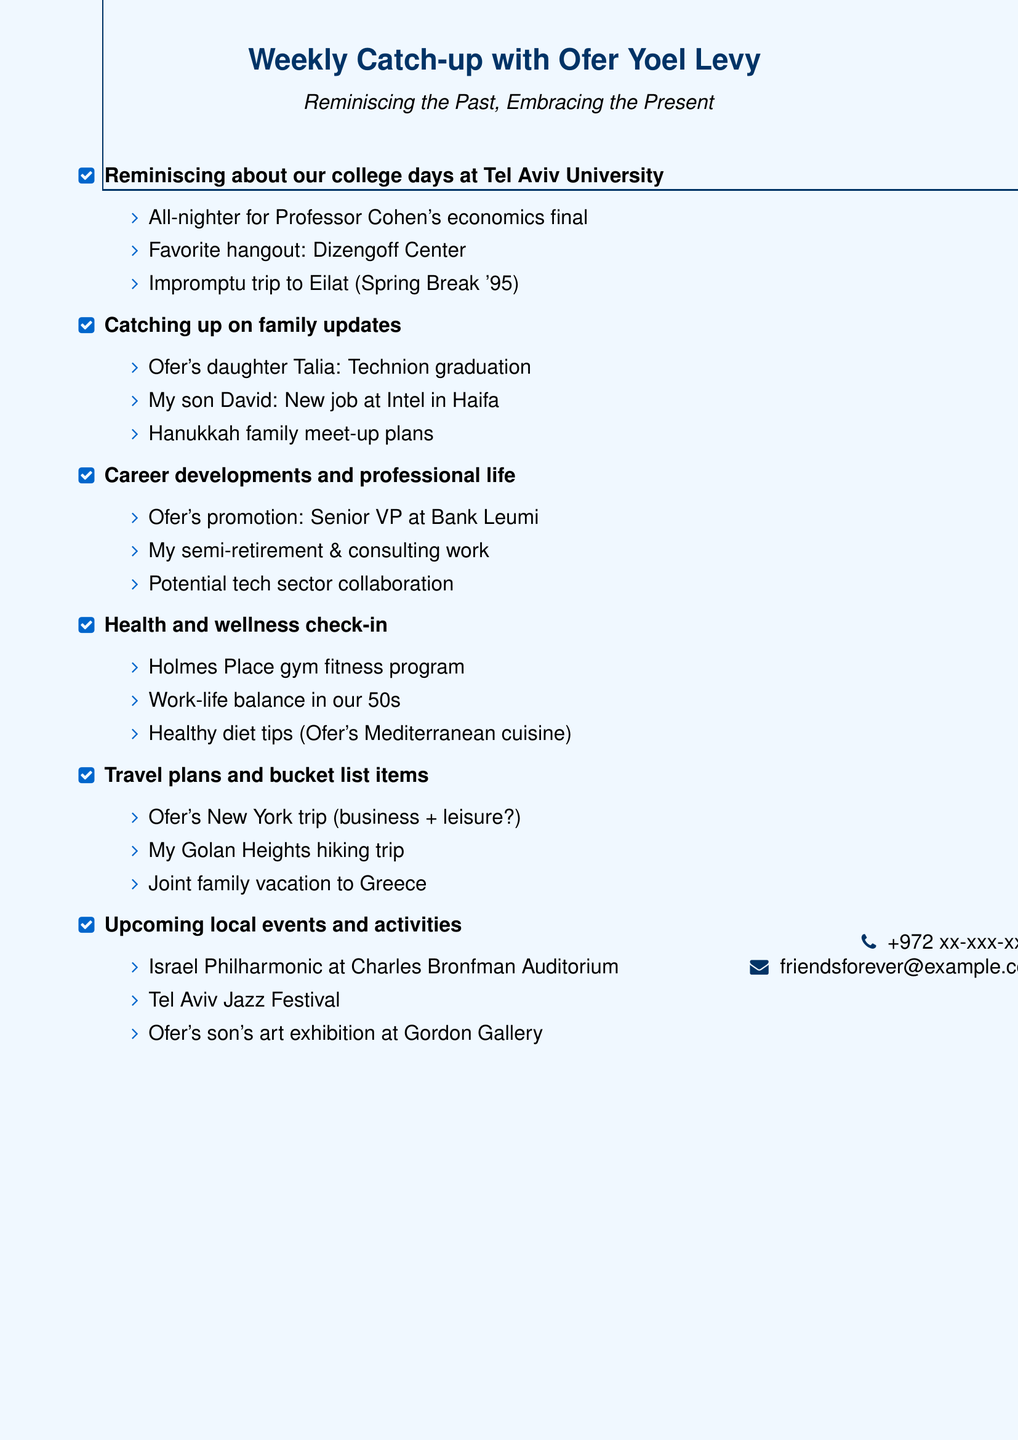What trip did Ofer and I take during spring break? The trip during spring break mentioned was an impromptu trip to Eilat in 1995.
Answer: Eilat What is the name of Ofer's daughter who graduated recently? Ofer's daughter who graduated is named Talia.
Answer: Talia What is Ofer's new position at Bank Leumi? Ofer's new position at Bank Leumi is Senior VP.
Answer: Senior VP What fitness program are we discussing in the health check-in? The fitness program being discussed is at Holmes Place gym.
Answer: Holmes Place gym What major region are my hiking plans for next month? The major region mentioned for hiking plans is the Golan Heights.
Answer: Golan Heights What type of cuisine has Ofer had success with for maintaining a healthy diet? Ofer has had success with Mediterranean cuisine for maintaining a healthy diet.
Answer: Mediterranean cuisine Where is Ofer's son's art exhibition taking place? Ofer's son's art exhibition is taking place at the Gordon Gallery.
Answer: Gordon Gallery What family celebration are we planning to meet up for? We are planning to meet up for the upcoming Hanukkah celebration.
Answer: Hanukkah What upcoming local event features the Israel Philharmonic Orchestra? The upcoming local event featuring the Israel Philharmonic Orchestra is at the Charles Bronfman Auditorium.
Answer: Charles Bronfman Auditorium 